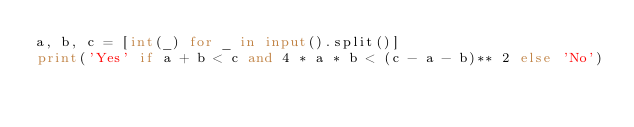Convert code to text. <code><loc_0><loc_0><loc_500><loc_500><_Python_>a, b, c = [int(_) for _ in input().split()]
print('Yes' if a + b < c and 4 * a * b < (c - a - b)** 2 else 'No')
</code> 